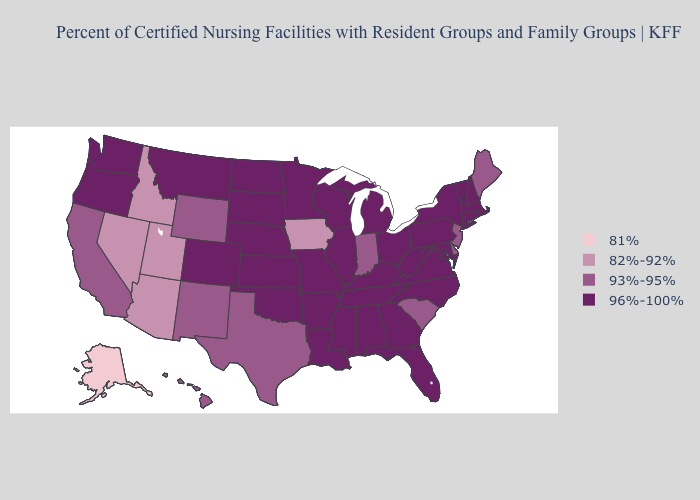Does Missouri have the lowest value in the USA?
Write a very short answer. No. Which states have the highest value in the USA?
Short answer required. Alabama, Arkansas, Colorado, Connecticut, Florida, Georgia, Illinois, Kansas, Kentucky, Louisiana, Maryland, Massachusetts, Michigan, Minnesota, Mississippi, Missouri, Montana, Nebraska, New Hampshire, New York, North Carolina, North Dakota, Ohio, Oklahoma, Oregon, Pennsylvania, Rhode Island, South Dakota, Tennessee, Vermont, Virginia, Washington, West Virginia, Wisconsin. What is the highest value in states that border Nevada?
Give a very brief answer. 96%-100%. Does Indiana have the lowest value in the MidWest?
Concise answer only. No. What is the value of New York?
Be succinct. 96%-100%. Name the states that have a value in the range 96%-100%?
Quick response, please. Alabama, Arkansas, Colorado, Connecticut, Florida, Georgia, Illinois, Kansas, Kentucky, Louisiana, Maryland, Massachusetts, Michigan, Minnesota, Mississippi, Missouri, Montana, Nebraska, New Hampshire, New York, North Carolina, North Dakota, Ohio, Oklahoma, Oregon, Pennsylvania, Rhode Island, South Dakota, Tennessee, Vermont, Virginia, Washington, West Virginia, Wisconsin. What is the value of Louisiana?
Short answer required. 96%-100%. Name the states that have a value in the range 96%-100%?
Quick response, please. Alabama, Arkansas, Colorado, Connecticut, Florida, Georgia, Illinois, Kansas, Kentucky, Louisiana, Maryland, Massachusetts, Michigan, Minnesota, Mississippi, Missouri, Montana, Nebraska, New Hampshire, New York, North Carolina, North Dakota, Ohio, Oklahoma, Oregon, Pennsylvania, Rhode Island, South Dakota, Tennessee, Vermont, Virginia, Washington, West Virginia, Wisconsin. Name the states that have a value in the range 93%-95%?
Be succinct. California, Delaware, Hawaii, Indiana, Maine, New Jersey, New Mexico, South Carolina, Texas, Wyoming. Which states have the highest value in the USA?
Write a very short answer. Alabama, Arkansas, Colorado, Connecticut, Florida, Georgia, Illinois, Kansas, Kentucky, Louisiana, Maryland, Massachusetts, Michigan, Minnesota, Mississippi, Missouri, Montana, Nebraska, New Hampshire, New York, North Carolina, North Dakota, Ohio, Oklahoma, Oregon, Pennsylvania, Rhode Island, South Dakota, Tennessee, Vermont, Virginia, Washington, West Virginia, Wisconsin. Does Nevada have a lower value than Nebraska?
Be succinct. Yes. Does Louisiana have a lower value than Iowa?
Concise answer only. No. Which states have the highest value in the USA?
Concise answer only. Alabama, Arkansas, Colorado, Connecticut, Florida, Georgia, Illinois, Kansas, Kentucky, Louisiana, Maryland, Massachusetts, Michigan, Minnesota, Mississippi, Missouri, Montana, Nebraska, New Hampshire, New York, North Carolina, North Dakota, Ohio, Oklahoma, Oregon, Pennsylvania, Rhode Island, South Dakota, Tennessee, Vermont, Virginia, Washington, West Virginia, Wisconsin. What is the highest value in states that border Nevada?
Write a very short answer. 96%-100%. Name the states that have a value in the range 81%?
Keep it brief. Alaska. 